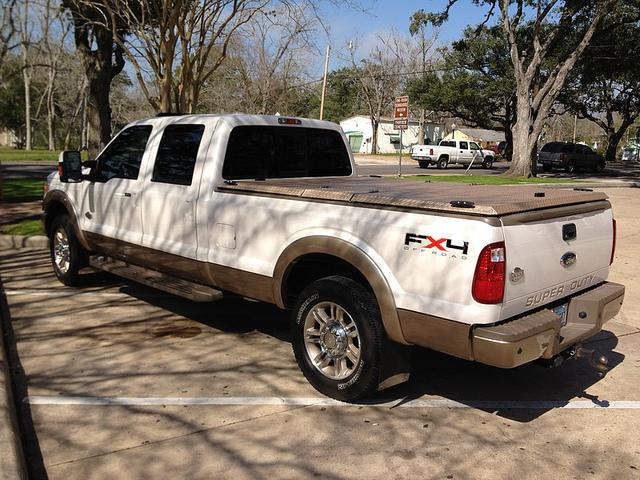What is the cover on the back of the truck called? tonneau cover 